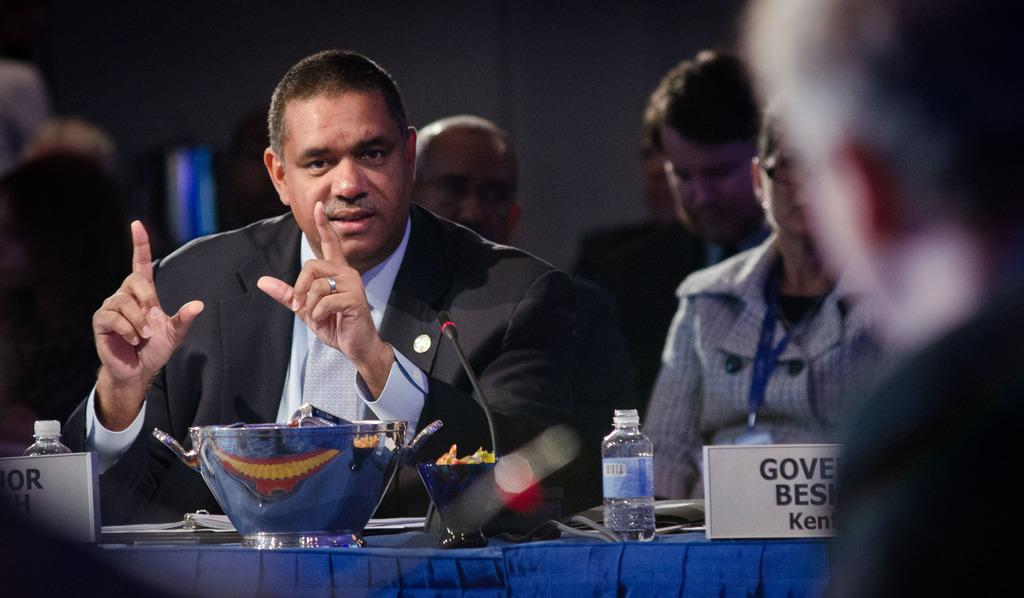Who or what can be seen in the image? There are people in the image. What objects are present that might be used for identification? There are name boards in the image. What device is visible that might be used for amplifying sound? A microphone is visible in the image. What type of containers can be seen in the image? There are bottles in the image. What is on the table in the image? There are objects on a table in the image. How would you describe the background of the image? The background of the image is blurry. How many dolls are sitting on the ship in the image? There are no dolls or ships present in the image. 